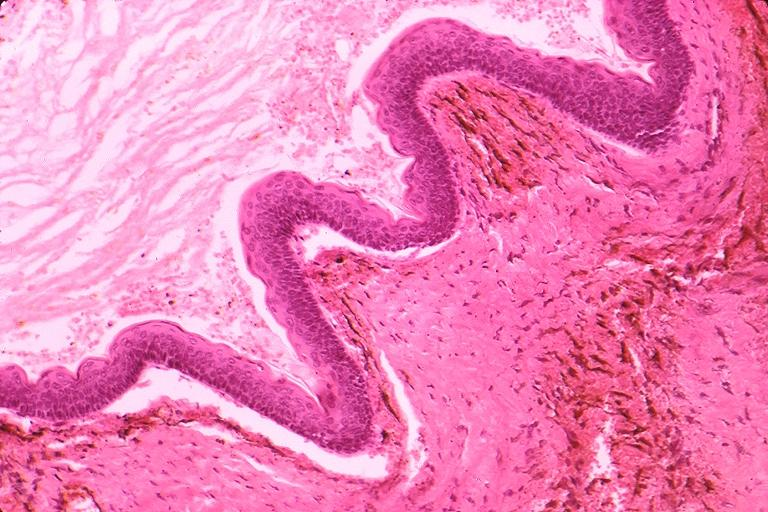s candida in peripheral blood present?
Answer the question using a single word or phrase. No 